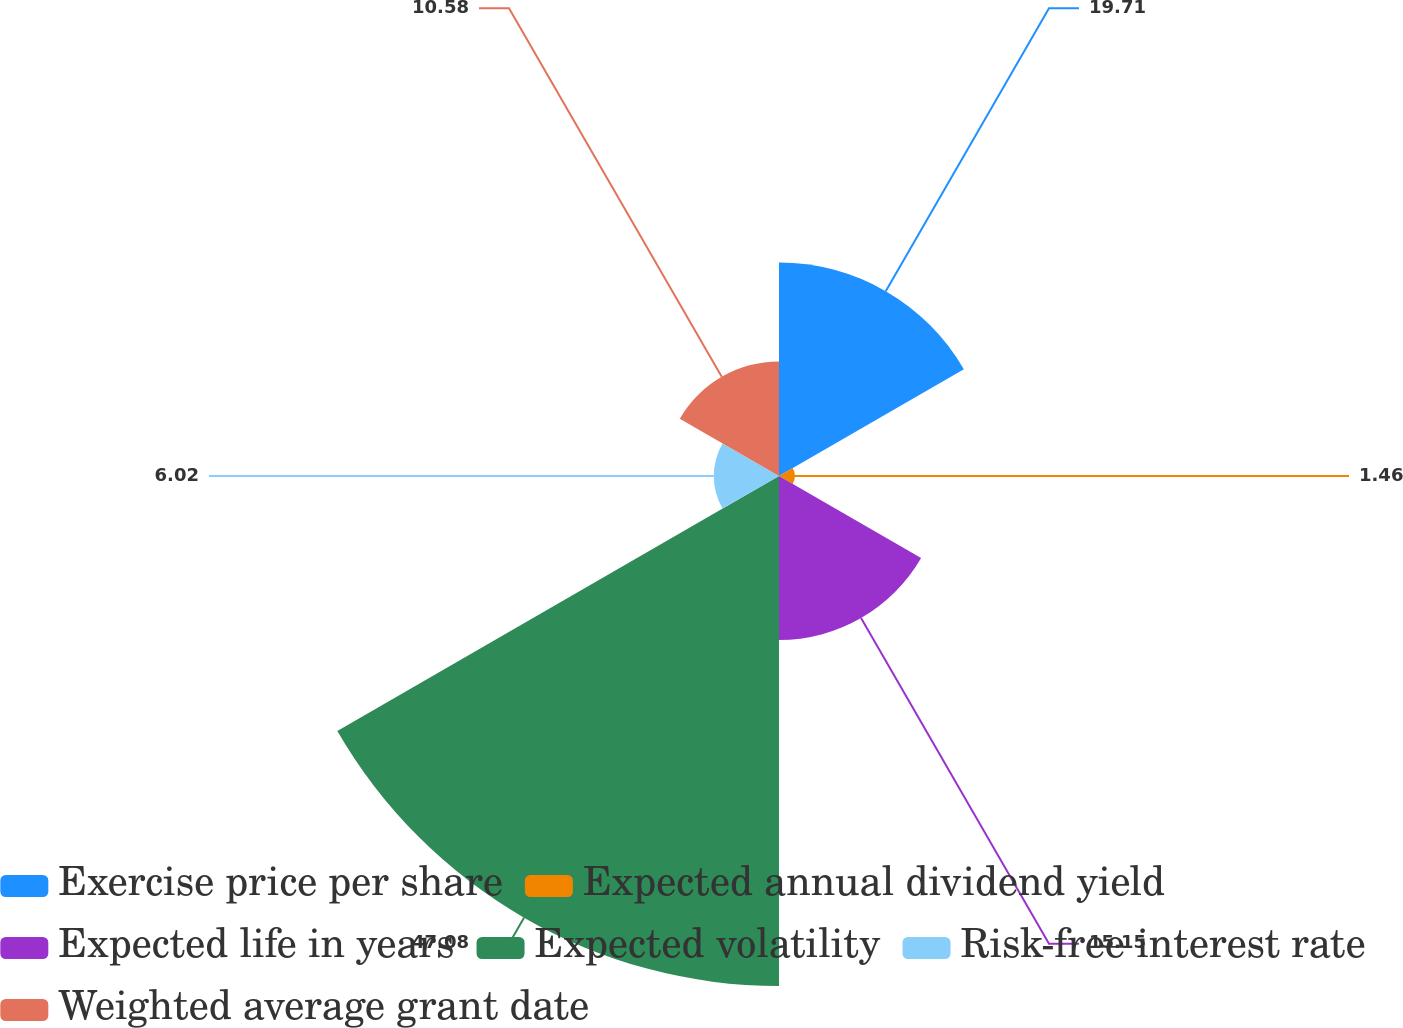Convert chart. <chart><loc_0><loc_0><loc_500><loc_500><pie_chart><fcel>Exercise price per share<fcel>Expected annual dividend yield<fcel>Expected life in years<fcel>Expected volatility<fcel>Risk-free interest rate<fcel>Weighted average grant date<nl><fcel>19.71%<fcel>1.46%<fcel>15.15%<fcel>47.09%<fcel>6.02%<fcel>10.58%<nl></chart> 